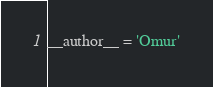<code> <loc_0><loc_0><loc_500><loc_500><_Python_>__author__ = 'Omur'
</code> 